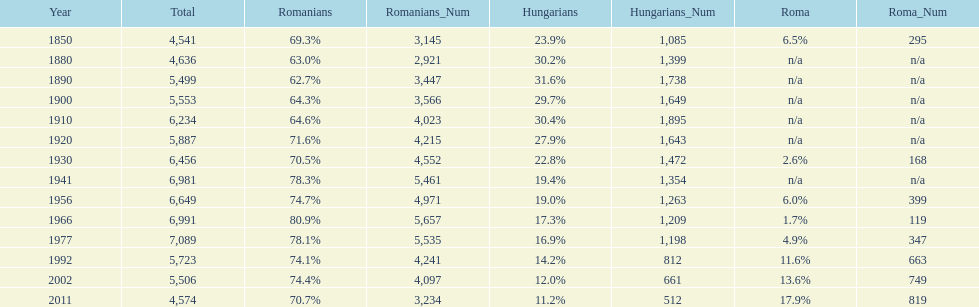What is the number of hungarians in 1850? 23.9%. 